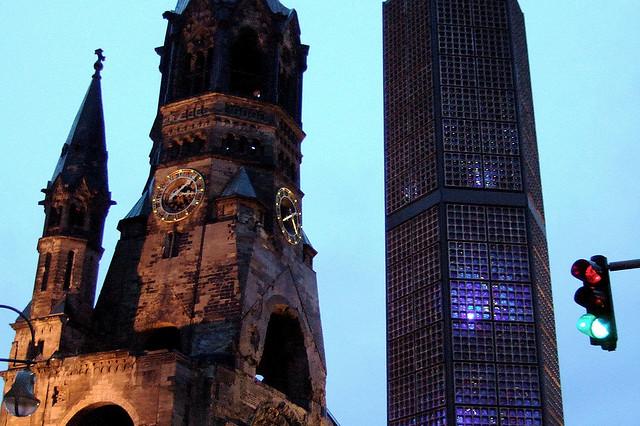What color traffic light is lit?
Answer briefly. Green. What time does the clock say?
Quick response, please. 3:10. What type of building is on the left?
Quick response, please. Church. 